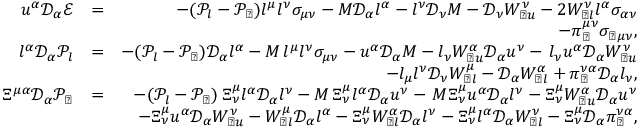Convert formula to latex. <formula><loc_0><loc_0><loc_500><loc_500>\begin{array} { r l r } { u ^ { \alpha } \mathcal { D } _ { \alpha } \mathcal { E } } & { = } & { - ( \mathcal { P } _ { l } - \mathcal { P } _ { \perp } ) l ^ { \mu } l ^ { \nu } \sigma _ { \mu \nu } - M \mathcal { D } _ { \alpha } l ^ { \alpha } - l ^ { \nu } \mathcal { D } _ { \nu } M - \mathcal { D } _ { \nu } W _ { \perp u } ^ { \nu } - 2 W _ { \perp l } ^ { \nu } l ^ { \alpha } \sigma _ { \alpha \nu } } \\ & { - \pi _ { \perp } ^ { \mu \nu } \sigma _ { \perp \mu \nu } , } \\ { l ^ { \alpha } \mathcal { D } _ { \alpha } \mathcal { P } _ { l } } & { = } & { - ( \mathcal { P } _ { l } - \mathcal { P } _ { \perp } ) \mathcal { D } _ { \alpha } l ^ { \alpha } - M \, l ^ { \mu } l ^ { \nu } \sigma _ { \mu \nu } - u ^ { \alpha } \mathcal { D } _ { \alpha } M - l _ { \nu } W _ { \perp u } ^ { \alpha } \mathcal { D } _ { \alpha } u ^ { \nu } - \, l _ { \nu } u ^ { \alpha } \mathcal { D } _ { \alpha } W _ { \perp u } ^ { \nu } } \\ & { - l _ { \mu } l ^ { \nu } \mathcal { D } _ { \nu } W _ { \perp l } ^ { \mu } - \mathcal { D } _ { \alpha } W _ { \perp l } ^ { \alpha } + \pi _ { \perp } ^ { \nu \alpha } \mathcal { D } _ { \alpha } l _ { \nu } , } \\ { \Xi ^ { \mu \alpha } \mathcal { D } _ { \alpha } \mathcal { P _ { \perp } } } & { = } & { - ( \mathcal { P } _ { l } - \mathcal { P } _ { \perp } ) \, \Xi _ { \nu } ^ { \mu } l ^ { \alpha } \mathcal { D } _ { \alpha } l ^ { \nu } - M \, \Xi _ { \nu } ^ { \mu } l ^ { \alpha } \mathcal { D } _ { \alpha } u ^ { \nu } - \, M \Xi _ { \nu } ^ { \mu } u ^ { \alpha } \mathcal { D } _ { \alpha } l ^ { \nu } - \Xi _ { \nu } ^ { \mu } W _ { \perp u } ^ { \alpha } \mathcal { D } _ { \alpha } u ^ { \nu } } \\ & { - \Xi _ { \nu } ^ { \mu } u ^ { \alpha } \mathcal { D } _ { \alpha } W _ { \perp u } ^ { \nu } - W _ { \perp l } ^ { \mu } \mathcal { D } _ { \alpha } l ^ { \alpha } - \Xi _ { \nu } ^ { \mu } W _ { \perp l } ^ { \alpha } \mathcal { D } _ { \alpha } l ^ { \nu } - \Xi _ { \nu } ^ { \mu } l ^ { \alpha } \mathcal { D } _ { \alpha } W _ { \perp l } ^ { \nu } - \Xi _ { \nu } ^ { \mu } \mathcal { D } _ { \alpha } \pi _ { \perp } ^ { \nu \alpha } , } \end{array}</formula> 